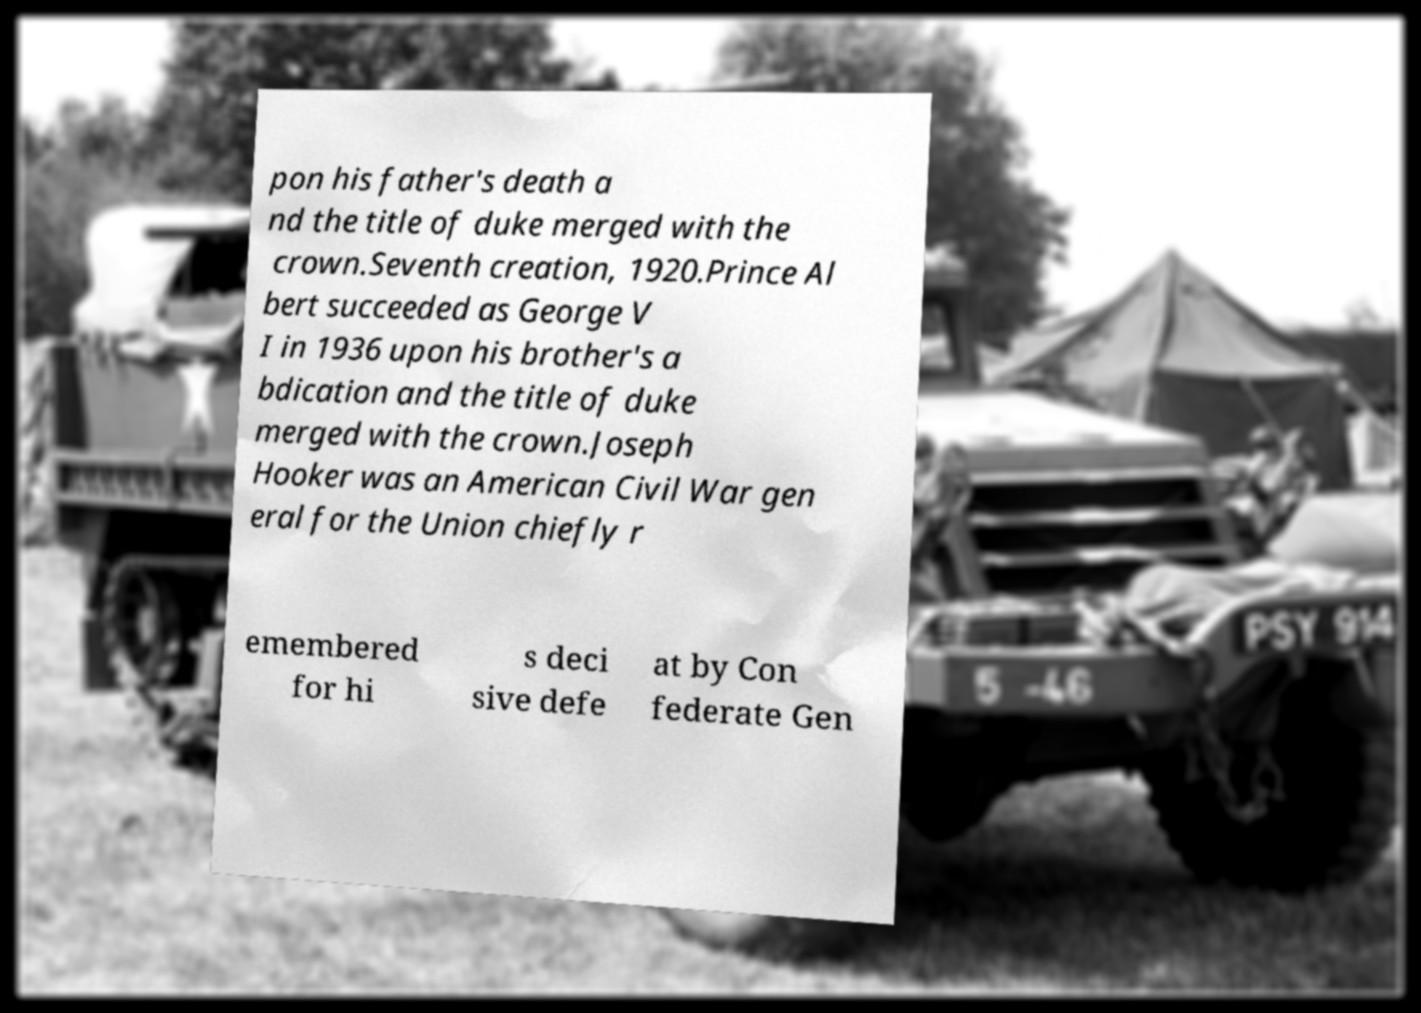Please identify and transcribe the text found in this image. pon his father's death a nd the title of duke merged with the crown.Seventh creation, 1920.Prince Al bert succeeded as George V I in 1936 upon his brother's a bdication and the title of duke merged with the crown.Joseph Hooker was an American Civil War gen eral for the Union chiefly r emembered for hi s deci sive defe at by Con federate Gen 